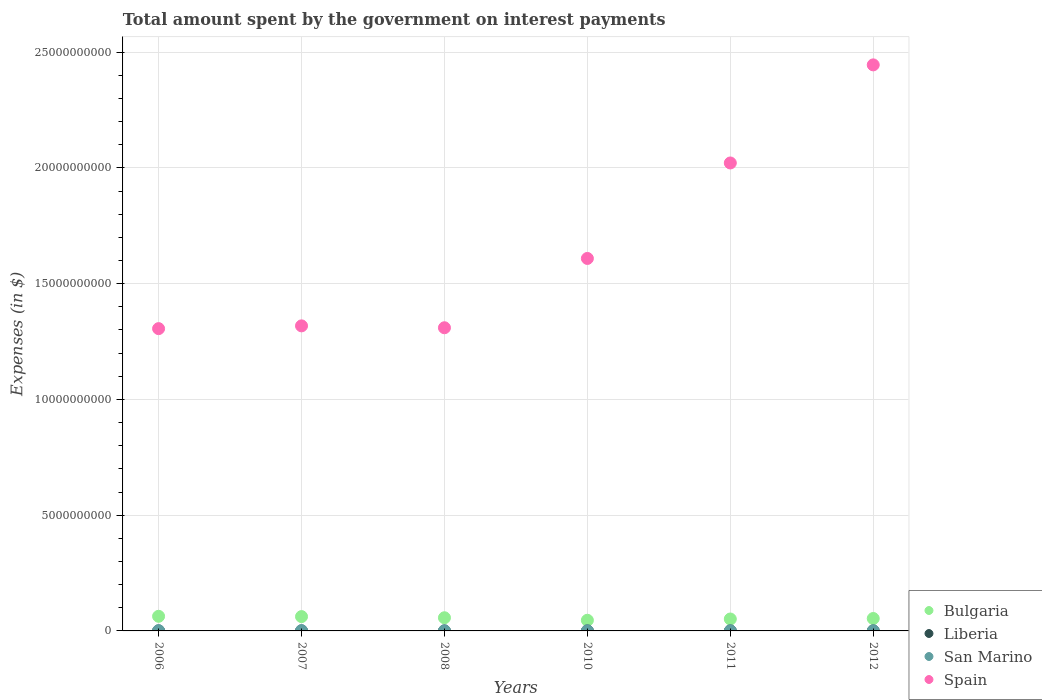What is the amount spent on interest payments by the government in San Marino in 2006?
Ensure brevity in your answer.  1.10e+07. Across all years, what is the maximum amount spent on interest payments by the government in San Marino?
Your answer should be compact. 1.27e+07. Across all years, what is the minimum amount spent on interest payments by the government in Bulgaria?
Provide a short and direct response. 4.60e+08. In which year was the amount spent on interest payments by the government in San Marino minimum?
Your answer should be compact. 2010. What is the total amount spent on interest payments by the government in Bulgaria in the graph?
Offer a very short reply. 3.33e+09. What is the difference between the amount spent on interest payments by the government in San Marino in 2010 and that in 2011?
Offer a terse response. -2.39e+05. What is the difference between the amount spent on interest payments by the government in Bulgaria in 2006 and the amount spent on interest payments by the government in Spain in 2010?
Ensure brevity in your answer.  -1.55e+1. What is the average amount spent on interest payments by the government in Bulgaria per year?
Give a very brief answer. 5.55e+08. In the year 2006, what is the difference between the amount spent on interest payments by the government in Liberia and amount spent on interest payments by the government in Spain?
Provide a succinct answer. -1.31e+1. In how many years, is the amount spent on interest payments by the government in San Marino greater than 8000000000 $?
Provide a short and direct response. 0. What is the ratio of the amount spent on interest payments by the government in Liberia in 2010 to that in 2011?
Offer a very short reply. 0.77. Is the difference between the amount spent on interest payments by the government in Liberia in 2006 and 2012 greater than the difference between the amount spent on interest payments by the government in Spain in 2006 and 2012?
Give a very brief answer. Yes. What is the difference between the highest and the second highest amount spent on interest payments by the government in Spain?
Make the answer very short. 4.24e+09. What is the difference between the highest and the lowest amount spent on interest payments by the government in Spain?
Ensure brevity in your answer.  1.14e+1. Is the sum of the amount spent on interest payments by the government in Bulgaria in 2008 and 2011 greater than the maximum amount spent on interest payments by the government in Spain across all years?
Your response must be concise. No. Is it the case that in every year, the sum of the amount spent on interest payments by the government in Liberia and amount spent on interest payments by the government in San Marino  is greater than the sum of amount spent on interest payments by the government in Spain and amount spent on interest payments by the government in Bulgaria?
Make the answer very short. No. Is it the case that in every year, the sum of the amount spent on interest payments by the government in San Marino and amount spent on interest payments by the government in Spain  is greater than the amount spent on interest payments by the government in Bulgaria?
Give a very brief answer. Yes. Does the amount spent on interest payments by the government in Bulgaria monotonically increase over the years?
Offer a terse response. No. Is the amount spent on interest payments by the government in San Marino strictly greater than the amount spent on interest payments by the government in Spain over the years?
Your answer should be very brief. No. Is the amount spent on interest payments by the government in San Marino strictly less than the amount spent on interest payments by the government in Liberia over the years?
Offer a very short reply. No. How many years are there in the graph?
Ensure brevity in your answer.  6. What is the difference between two consecutive major ticks on the Y-axis?
Give a very brief answer. 5.00e+09. How many legend labels are there?
Your answer should be very brief. 4. How are the legend labels stacked?
Offer a terse response. Vertical. What is the title of the graph?
Provide a succinct answer. Total amount spent by the government on interest payments. What is the label or title of the Y-axis?
Offer a terse response. Expenses (in $). What is the Expenses (in $) in Bulgaria in 2006?
Offer a very short reply. 6.32e+08. What is the Expenses (in $) in Liberia in 2006?
Provide a succinct answer. 2.07e+04. What is the Expenses (in $) in San Marino in 2006?
Give a very brief answer. 1.10e+07. What is the Expenses (in $) of Spain in 2006?
Keep it short and to the point. 1.31e+1. What is the Expenses (in $) in Bulgaria in 2007?
Your answer should be compact. 6.19e+08. What is the Expenses (in $) in Liberia in 2007?
Make the answer very short. 2.20e+04. What is the Expenses (in $) in San Marino in 2007?
Your answer should be compact. 1.27e+07. What is the Expenses (in $) in Spain in 2007?
Your answer should be compact. 1.32e+1. What is the Expenses (in $) of Bulgaria in 2008?
Give a very brief answer. 5.69e+08. What is the Expenses (in $) in Liberia in 2008?
Offer a very short reply. 7.01e+04. What is the Expenses (in $) of San Marino in 2008?
Your answer should be compact. 5.97e+06. What is the Expenses (in $) in Spain in 2008?
Give a very brief answer. 1.31e+1. What is the Expenses (in $) in Bulgaria in 2010?
Make the answer very short. 4.60e+08. What is the Expenses (in $) of Liberia in 2010?
Make the answer very short. 1.88e+05. What is the Expenses (in $) of San Marino in 2010?
Your answer should be very brief. 4.65e+06. What is the Expenses (in $) in Spain in 2010?
Your answer should be very brief. 1.61e+1. What is the Expenses (in $) in Bulgaria in 2011?
Provide a succinct answer. 5.15e+08. What is the Expenses (in $) of Liberia in 2011?
Keep it short and to the point. 2.44e+05. What is the Expenses (in $) of San Marino in 2011?
Your response must be concise. 4.89e+06. What is the Expenses (in $) in Spain in 2011?
Keep it short and to the point. 2.02e+1. What is the Expenses (in $) of Bulgaria in 2012?
Keep it short and to the point. 5.36e+08. What is the Expenses (in $) of Liberia in 2012?
Your answer should be compact. 4.63e+04. What is the Expenses (in $) of San Marino in 2012?
Offer a terse response. 5.06e+06. What is the Expenses (in $) in Spain in 2012?
Provide a succinct answer. 2.44e+1. Across all years, what is the maximum Expenses (in $) of Bulgaria?
Your answer should be very brief. 6.32e+08. Across all years, what is the maximum Expenses (in $) in Liberia?
Provide a short and direct response. 2.44e+05. Across all years, what is the maximum Expenses (in $) in San Marino?
Provide a succinct answer. 1.27e+07. Across all years, what is the maximum Expenses (in $) in Spain?
Your response must be concise. 2.44e+1. Across all years, what is the minimum Expenses (in $) in Bulgaria?
Provide a succinct answer. 4.60e+08. Across all years, what is the minimum Expenses (in $) in Liberia?
Offer a very short reply. 2.07e+04. Across all years, what is the minimum Expenses (in $) in San Marino?
Keep it short and to the point. 4.65e+06. Across all years, what is the minimum Expenses (in $) of Spain?
Your answer should be compact. 1.31e+1. What is the total Expenses (in $) in Bulgaria in the graph?
Provide a succinct answer. 3.33e+09. What is the total Expenses (in $) of Liberia in the graph?
Your response must be concise. 5.92e+05. What is the total Expenses (in $) of San Marino in the graph?
Your response must be concise. 4.43e+07. What is the total Expenses (in $) of Spain in the graph?
Keep it short and to the point. 1.00e+11. What is the difference between the Expenses (in $) in Bulgaria in 2006 and that in 2007?
Give a very brief answer. 1.30e+07. What is the difference between the Expenses (in $) in Liberia in 2006 and that in 2007?
Provide a succinct answer. -1373.52. What is the difference between the Expenses (in $) of San Marino in 2006 and that in 2007?
Keep it short and to the point. -1.77e+06. What is the difference between the Expenses (in $) in Spain in 2006 and that in 2007?
Provide a succinct answer. -1.20e+08. What is the difference between the Expenses (in $) in Bulgaria in 2006 and that in 2008?
Offer a very short reply. 6.30e+07. What is the difference between the Expenses (in $) in Liberia in 2006 and that in 2008?
Provide a succinct answer. -4.94e+04. What is the difference between the Expenses (in $) in San Marino in 2006 and that in 2008?
Ensure brevity in your answer.  5.00e+06. What is the difference between the Expenses (in $) in Spain in 2006 and that in 2008?
Offer a terse response. -3.80e+07. What is the difference between the Expenses (in $) of Bulgaria in 2006 and that in 2010?
Provide a short and direct response. 1.72e+08. What is the difference between the Expenses (in $) in Liberia in 2006 and that in 2010?
Your response must be concise. -1.68e+05. What is the difference between the Expenses (in $) in San Marino in 2006 and that in 2010?
Provide a short and direct response. 6.32e+06. What is the difference between the Expenses (in $) in Spain in 2006 and that in 2010?
Ensure brevity in your answer.  -3.03e+09. What is the difference between the Expenses (in $) in Bulgaria in 2006 and that in 2011?
Your answer should be very brief. 1.17e+08. What is the difference between the Expenses (in $) of Liberia in 2006 and that in 2011?
Your answer should be very brief. -2.24e+05. What is the difference between the Expenses (in $) of San Marino in 2006 and that in 2011?
Your answer should be very brief. 6.08e+06. What is the difference between the Expenses (in $) of Spain in 2006 and that in 2011?
Offer a very short reply. -7.16e+09. What is the difference between the Expenses (in $) of Bulgaria in 2006 and that in 2012?
Give a very brief answer. 9.56e+07. What is the difference between the Expenses (in $) in Liberia in 2006 and that in 2012?
Make the answer very short. -2.57e+04. What is the difference between the Expenses (in $) of San Marino in 2006 and that in 2012?
Provide a short and direct response. 5.90e+06. What is the difference between the Expenses (in $) in Spain in 2006 and that in 2012?
Your answer should be very brief. -1.14e+1. What is the difference between the Expenses (in $) in Bulgaria in 2007 and that in 2008?
Your answer should be compact. 5.00e+07. What is the difference between the Expenses (in $) of Liberia in 2007 and that in 2008?
Your answer should be compact. -4.80e+04. What is the difference between the Expenses (in $) of San Marino in 2007 and that in 2008?
Your response must be concise. 6.77e+06. What is the difference between the Expenses (in $) of Spain in 2007 and that in 2008?
Your response must be concise. 8.20e+07. What is the difference between the Expenses (in $) in Bulgaria in 2007 and that in 2010?
Provide a succinct answer. 1.59e+08. What is the difference between the Expenses (in $) in Liberia in 2007 and that in 2010?
Provide a succinct answer. -1.66e+05. What is the difference between the Expenses (in $) of San Marino in 2007 and that in 2010?
Your response must be concise. 8.09e+06. What is the difference between the Expenses (in $) of Spain in 2007 and that in 2010?
Provide a short and direct response. -2.91e+09. What is the difference between the Expenses (in $) of Bulgaria in 2007 and that in 2011?
Keep it short and to the point. 1.04e+08. What is the difference between the Expenses (in $) in Liberia in 2007 and that in 2011?
Your answer should be very brief. -2.22e+05. What is the difference between the Expenses (in $) of San Marino in 2007 and that in 2011?
Give a very brief answer. 7.85e+06. What is the difference between the Expenses (in $) of Spain in 2007 and that in 2011?
Ensure brevity in your answer.  -7.04e+09. What is the difference between the Expenses (in $) in Bulgaria in 2007 and that in 2012?
Offer a very short reply. 8.26e+07. What is the difference between the Expenses (in $) in Liberia in 2007 and that in 2012?
Your response must be concise. -2.43e+04. What is the difference between the Expenses (in $) of San Marino in 2007 and that in 2012?
Offer a terse response. 7.67e+06. What is the difference between the Expenses (in $) in Spain in 2007 and that in 2012?
Ensure brevity in your answer.  -1.13e+1. What is the difference between the Expenses (in $) of Bulgaria in 2008 and that in 2010?
Offer a very short reply. 1.09e+08. What is the difference between the Expenses (in $) of Liberia in 2008 and that in 2010?
Keep it short and to the point. -1.18e+05. What is the difference between the Expenses (in $) in San Marino in 2008 and that in 2010?
Ensure brevity in your answer.  1.32e+06. What is the difference between the Expenses (in $) of Spain in 2008 and that in 2010?
Offer a terse response. -2.99e+09. What is the difference between the Expenses (in $) of Bulgaria in 2008 and that in 2011?
Make the answer very short. 5.42e+07. What is the difference between the Expenses (in $) of Liberia in 2008 and that in 2011?
Keep it short and to the point. -1.74e+05. What is the difference between the Expenses (in $) of San Marino in 2008 and that in 2011?
Ensure brevity in your answer.  1.08e+06. What is the difference between the Expenses (in $) of Spain in 2008 and that in 2011?
Provide a succinct answer. -7.12e+09. What is the difference between the Expenses (in $) of Bulgaria in 2008 and that in 2012?
Keep it short and to the point. 3.26e+07. What is the difference between the Expenses (in $) of Liberia in 2008 and that in 2012?
Your answer should be very brief. 2.38e+04. What is the difference between the Expenses (in $) in San Marino in 2008 and that in 2012?
Offer a very short reply. 9.05e+05. What is the difference between the Expenses (in $) in Spain in 2008 and that in 2012?
Offer a terse response. -1.14e+1. What is the difference between the Expenses (in $) in Bulgaria in 2010 and that in 2011?
Ensure brevity in your answer.  -5.47e+07. What is the difference between the Expenses (in $) of Liberia in 2010 and that in 2011?
Your response must be concise. -5.61e+04. What is the difference between the Expenses (in $) of San Marino in 2010 and that in 2011?
Your answer should be compact. -2.39e+05. What is the difference between the Expenses (in $) of Spain in 2010 and that in 2011?
Provide a short and direct response. -4.12e+09. What is the difference between the Expenses (in $) of Bulgaria in 2010 and that in 2012?
Ensure brevity in your answer.  -7.62e+07. What is the difference between the Expenses (in $) of Liberia in 2010 and that in 2012?
Keep it short and to the point. 1.42e+05. What is the difference between the Expenses (in $) of San Marino in 2010 and that in 2012?
Your response must be concise. -4.13e+05. What is the difference between the Expenses (in $) in Spain in 2010 and that in 2012?
Keep it short and to the point. -8.36e+09. What is the difference between the Expenses (in $) of Bulgaria in 2011 and that in 2012?
Offer a terse response. -2.16e+07. What is the difference between the Expenses (in $) in Liberia in 2011 and that in 2012?
Your answer should be compact. 1.98e+05. What is the difference between the Expenses (in $) of San Marino in 2011 and that in 2012?
Your answer should be compact. -1.75e+05. What is the difference between the Expenses (in $) of Spain in 2011 and that in 2012?
Keep it short and to the point. -4.24e+09. What is the difference between the Expenses (in $) in Bulgaria in 2006 and the Expenses (in $) in Liberia in 2007?
Provide a succinct answer. 6.32e+08. What is the difference between the Expenses (in $) of Bulgaria in 2006 and the Expenses (in $) of San Marino in 2007?
Make the answer very short. 6.19e+08. What is the difference between the Expenses (in $) of Bulgaria in 2006 and the Expenses (in $) of Spain in 2007?
Your response must be concise. -1.25e+1. What is the difference between the Expenses (in $) in Liberia in 2006 and the Expenses (in $) in San Marino in 2007?
Provide a succinct answer. -1.27e+07. What is the difference between the Expenses (in $) in Liberia in 2006 and the Expenses (in $) in Spain in 2007?
Offer a terse response. -1.32e+1. What is the difference between the Expenses (in $) of San Marino in 2006 and the Expenses (in $) of Spain in 2007?
Make the answer very short. -1.32e+1. What is the difference between the Expenses (in $) in Bulgaria in 2006 and the Expenses (in $) in Liberia in 2008?
Ensure brevity in your answer.  6.32e+08. What is the difference between the Expenses (in $) in Bulgaria in 2006 and the Expenses (in $) in San Marino in 2008?
Make the answer very short. 6.26e+08. What is the difference between the Expenses (in $) in Bulgaria in 2006 and the Expenses (in $) in Spain in 2008?
Keep it short and to the point. -1.25e+1. What is the difference between the Expenses (in $) in Liberia in 2006 and the Expenses (in $) in San Marino in 2008?
Provide a short and direct response. -5.95e+06. What is the difference between the Expenses (in $) of Liberia in 2006 and the Expenses (in $) of Spain in 2008?
Give a very brief answer. -1.31e+1. What is the difference between the Expenses (in $) of San Marino in 2006 and the Expenses (in $) of Spain in 2008?
Your response must be concise. -1.31e+1. What is the difference between the Expenses (in $) of Bulgaria in 2006 and the Expenses (in $) of Liberia in 2010?
Give a very brief answer. 6.32e+08. What is the difference between the Expenses (in $) of Bulgaria in 2006 and the Expenses (in $) of San Marino in 2010?
Provide a succinct answer. 6.27e+08. What is the difference between the Expenses (in $) in Bulgaria in 2006 and the Expenses (in $) in Spain in 2010?
Keep it short and to the point. -1.55e+1. What is the difference between the Expenses (in $) in Liberia in 2006 and the Expenses (in $) in San Marino in 2010?
Give a very brief answer. -4.63e+06. What is the difference between the Expenses (in $) in Liberia in 2006 and the Expenses (in $) in Spain in 2010?
Your answer should be very brief. -1.61e+1. What is the difference between the Expenses (in $) of San Marino in 2006 and the Expenses (in $) of Spain in 2010?
Your answer should be compact. -1.61e+1. What is the difference between the Expenses (in $) of Bulgaria in 2006 and the Expenses (in $) of Liberia in 2011?
Keep it short and to the point. 6.31e+08. What is the difference between the Expenses (in $) in Bulgaria in 2006 and the Expenses (in $) in San Marino in 2011?
Provide a short and direct response. 6.27e+08. What is the difference between the Expenses (in $) of Bulgaria in 2006 and the Expenses (in $) of Spain in 2011?
Provide a succinct answer. -1.96e+1. What is the difference between the Expenses (in $) in Liberia in 2006 and the Expenses (in $) in San Marino in 2011?
Ensure brevity in your answer.  -4.87e+06. What is the difference between the Expenses (in $) of Liberia in 2006 and the Expenses (in $) of Spain in 2011?
Offer a terse response. -2.02e+1. What is the difference between the Expenses (in $) in San Marino in 2006 and the Expenses (in $) in Spain in 2011?
Your response must be concise. -2.02e+1. What is the difference between the Expenses (in $) of Bulgaria in 2006 and the Expenses (in $) of Liberia in 2012?
Your answer should be compact. 6.32e+08. What is the difference between the Expenses (in $) of Bulgaria in 2006 and the Expenses (in $) of San Marino in 2012?
Ensure brevity in your answer.  6.27e+08. What is the difference between the Expenses (in $) in Bulgaria in 2006 and the Expenses (in $) in Spain in 2012?
Make the answer very short. -2.38e+1. What is the difference between the Expenses (in $) of Liberia in 2006 and the Expenses (in $) of San Marino in 2012?
Your answer should be compact. -5.04e+06. What is the difference between the Expenses (in $) of Liberia in 2006 and the Expenses (in $) of Spain in 2012?
Provide a succinct answer. -2.44e+1. What is the difference between the Expenses (in $) in San Marino in 2006 and the Expenses (in $) in Spain in 2012?
Provide a succinct answer. -2.44e+1. What is the difference between the Expenses (in $) in Bulgaria in 2007 and the Expenses (in $) in Liberia in 2008?
Keep it short and to the point. 6.19e+08. What is the difference between the Expenses (in $) of Bulgaria in 2007 and the Expenses (in $) of San Marino in 2008?
Your response must be concise. 6.13e+08. What is the difference between the Expenses (in $) of Bulgaria in 2007 and the Expenses (in $) of Spain in 2008?
Provide a succinct answer. -1.25e+1. What is the difference between the Expenses (in $) of Liberia in 2007 and the Expenses (in $) of San Marino in 2008?
Provide a succinct answer. -5.95e+06. What is the difference between the Expenses (in $) of Liberia in 2007 and the Expenses (in $) of Spain in 2008?
Offer a very short reply. -1.31e+1. What is the difference between the Expenses (in $) of San Marino in 2007 and the Expenses (in $) of Spain in 2008?
Your response must be concise. -1.31e+1. What is the difference between the Expenses (in $) in Bulgaria in 2007 and the Expenses (in $) in Liberia in 2010?
Ensure brevity in your answer.  6.19e+08. What is the difference between the Expenses (in $) of Bulgaria in 2007 and the Expenses (in $) of San Marino in 2010?
Your answer should be compact. 6.14e+08. What is the difference between the Expenses (in $) of Bulgaria in 2007 and the Expenses (in $) of Spain in 2010?
Keep it short and to the point. -1.55e+1. What is the difference between the Expenses (in $) in Liberia in 2007 and the Expenses (in $) in San Marino in 2010?
Keep it short and to the point. -4.63e+06. What is the difference between the Expenses (in $) in Liberia in 2007 and the Expenses (in $) in Spain in 2010?
Give a very brief answer. -1.61e+1. What is the difference between the Expenses (in $) in San Marino in 2007 and the Expenses (in $) in Spain in 2010?
Ensure brevity in your answer.  -1.61e+1. What is the difference between the Expenses (in $) of Bulgaria in 2007 and the Expenses (in $) of Liberia in 2011?
Offer a terse response. 6.18e+08. What is the difference between the Expenses (in $) of Bulgaria in 2007 and the Expenses (in $) of San Marino in 2011?
Ensure brevity in your answer.  6.14e+08. What is the difference between the Expenses (in $) in Bulgaria in 2007 and the Expenses (in $) in Spain in 2011?
Give a very brief answer. -1.96e+1. What is the difference between the Expenses (in $) in Liberia in 2007 and the Expenses (in $) in San Marino in 2011?
Give a very brief answer. -4.87e+06. What is the difference between the Expenses (in $) in Liberia in 2007 and the Expenses (in $) in Spain in 2011?
Give a very brief answer. -2.02e+1. What is the difference between the Expenses (in $) in San Marino in 2007 and the Expenses (in $) in Spain in 2011?
Provide a succinct answer. -2.02e+1. What is the difference between the Expenses (in $) of Bulgaria in 2007 and the Expenses (in $) of Liberia in 2012?
Offer a terse response. 6.19e+08. What is the difference between the Expenses (in $) in Bulgaria in 2007 and the Expenses (in $) in San Marino in 2012?
Offer a very short reply. 6.14e+08. What is the difference between the Expenses (in $) of Bulgaria in 2007 and the Expenses (in $) of Spain in 2012?
Give a very brief answer. -2.38e+1. What is the difference between the Expenses (in $) in Liberia in 2007 and the Expenses (in $) in San Marino in 2012?
Make the answer very short. -5.04e+06. What is the difference between the Expenses (in $) in Liberia in 2007 and the Expenses (in $) in Spain in 2012?
Give a very brief answer. -2.44e+1. What is the difference between the Expenses (in $) in San Marino in 2007 and the Expenses (in $) in Spain in 2012?
Your answer should be very brief. -2.44e+1. What is the difference between the Expenses (in $) in Bulgaria in 2008 and the Expenses (in $) in Liberia in 2010?
Provide a short and direct response. 5.69e+08. What is the difference between the Expenses (in $) of Bulgaria in 2008 and the Expenses (in $) of San Marino in 2010?
Offer a terse response. 5.64e+08. What is the difference between the Expenses (in $) in Bulgaria in 2008 and the Expenses (in $) in Spain in 2010?
Offer a very short reply. -1.55e+1. What is the difference between the Expenses (in $) of Liberia in 2008 and the Expenses (in $) of San Marino in 2010?
Keep it short and to the point. -4.58e+06. What is the difference between the Expenses (in $) of Liberia in 2008 and the Expenses (in $) of Spain in 2010?
Make the answer very short. -1.61e+1. What is the difference between the Expenses (in $) in San Marino in 2008 and the Expenses (in $) in Spain in 2010?
Your answer should be very brief. -1.61e+1. What is the difference between the Expenses (in $) in Bulgaria in 2008 and the Expenses (in $) in Liberia in 2011?
Make the answer very short. 5.69e+08. What is the difference between the Expenses (in $) in Bulgaria in 2008 and the Expenses (in $) in San Marino in 2011?
Offer a terse response. 5.64e+08. What is the difference between the Expenses (in $) of Bulgaria in 2008 and the Expenses (in $) of Spain in 2011?
Make the answer very short. -1.96e+1. What is the difference between the Expenses (in $) of Liberia in 2008 and the Expenses (in $) of San Marino in 2011?
Make the answer very short. -4.82e+06. What is the difference between the Expenses (in $) of Liberia in 2008 and the Expenses (in $) of Spain in 2011?
Make the answer very short. -2.02e+1. What is the difference between the Expenses (in $) of San Marino in 2008 and the Expenses (in $) of Spain in 2011?
Give a very brief answer. -2.02e+1. What is the difference between the Expenses (in $) in Bulgaria in 2008 and the Expenses (in $) in Liberia in 2012?
Give a very brief answer. 5.69e+08. What is the difference between the Expenses (in $) in Bulgaria in 2008 and the Expenses (in $) in San Marino in 2012?
Offer a very short reply. 5.64e+08. What is the difference between the Expenses (in $) of Bulgaria in 2008 and the Expenses (in $) of Spain in 2012?
Ensure brevity in your answer.  -2.39e+1. What is the difference between the Expenses (in $) of Liberia in 2008 and the Expenses (in $) of San Marino in 2012?
Your answer should be very brief. -4.99e+06. What is the difference between the Expenses (in $) in Liberia in 2008 and the Expenses (in $) in Spain in 2012?
Ensure brevity in your answer.  -2.44e+1. What is the difference between the Expenses (in $) in San Marino in 2008 and the Expenses (in $) in Spain in 2012?
Provide a succinct answer. -2.44e+1. What is the difference between the Expenses (in $) in Bulgaria in 2010 and the Expenses (in $) in Liberia in 2011?
Your answer should be very brief. 4.60e+08. What is the difference between the Expenses (in $) in Bulgaria in 2010 and the Expenses (in $) in San Marino in 2011?
Provide a succinct answer. 4.55e+08. What is the difference between the Expenses (in $) of Bulgaria in 2010 and the Expenses (in $) of Spain in 2011?
Provide a short and direct response. -1.98e+1. What is the difference between the Expenses (in $) of Liberia in 2010 and the Expenses (in $) of San Marino in 2011?
Make the answer very short. -4.70e+06. What is the difference between the Expenses (in $) of Liberia in 2010 and the Expenses (in $) of Spain in 2011?
Offer a terse response. -2.02e+1. What is the difference between the Expenses (in $) in San Marino in 2010 and the Expenses (in $) in Spain in 2011?
Ensure brevity in your answer.  -2.02e+1. What is the difference between the Expenses (in $) in Bulgaria in 2010 and the Expenses (in $) in Liberia in 2012?
Your response must be concise. 4.60e+08. What is the difference between the Expenses (in $) of Bulgaria in 2010 and the Expenses (in $) of San Marino in 2012?
Make the answer very short. 4.55e+08. What is the difference between the Expenses (in $) in Bulgaria in 2010 and the Expenses (in $) in Spain in 2012?
Your answer should be very brief. -2.40e+1. What is the difference between the Expenses (in $) in Liberia in 2010 and the Expenses (in $) in San Marino in 2012?
Offer a very short reply. -4.88e+06. What is the difference between the Expenses (in $) in Liberia in 2010 and the Expenses (in $) in Spain in 2012?
Give a very brief answer. -2.44e+1. What is the difference between the Expenses (in $) in San Marino in 2010 and the Expenses (in $) in Spain in 2012?
Keep it short and to the point. -2.44e+1. What is the difference between the Expenses (in $) in Bulgaria in 2011 and the Expenses (in $) in Liberia in 2012?
Offer a terse response. 5.15e+08. What is the difference between the Expenses (in $) in Bulgaria in 2011 and the Expenses (in $) in San Marino in 2012?
Offer a terse response. 5.10e+08. What is the difference between the Expenses (in $) of Bulgaria in 2011 and the Expenses (in $) of Spain in 2012?
Your answer should be compact. -2.39e+1. What is the difference between the Expenses (in $) of Liberia in 2011 and the Expenses (in $) of San Marino in 2012?
Offer a terse response. -4.82e+06. What is the difference between the Expenses (in $) of Liberia in 2011 and the Expenses (in $) of Spain in 2012?
Keep it short and to the point. -2.44e+1. What is the difference between the Expenses (in $) of San Marino in 2011 and the Expenses (in $) of Spain in 2012?
Offer a very short reply. -2.44e+1. What is the average Expenses (in $) in Bulgaria per year?
Keep it short and to the point. 5.55e+08. What is the average Expenses (in $) in Liberia per year?
Your answer should be compact. 9.86e+04. What is the average Expenses (in $) of San Marino per year?
Your answer should be very brief. 7.38e+06. What is the average Expenses (in $) of Spain per year?
Ensure brevity in your answer.  1.67e+1. In the year 2006, what is the difference between the Expenses (in $) of Bulgaria and Expenses (in $) of Liberia?
Your answer should be compact. 6.32e+08. In the year 2006, what is the difference between the Expenses (in $) of Bulgaria and Expenses (in $) of San Marino?
Provide a short and direct response. 6.21e+08. In the year 2006, what is the difference between the Expenses (in $) of Bulgaria and Expenses (in $) of Spain?
Provide a short and direct response. -1.24e+1. In the year 2006, what is the difference between the Expenses (in $) of Liberia and Expenses (in $) of San Marino?
Your answer should be compact. -1.09e+07. In the year 2006, what is the difference between the Expenses (in $) of Liberia and Expenses (in $) of Spain?
Your response must be concise. -1.31e+1. In the year 2006, what is the difference between the Expenses (in $) in San Marino and Expenses (in $) in Spain?
Provide a short and direct response. -1.30e+1. In the year 2007, what is the difference between the Expenses (in $) in Bulgaria and Expenses (in $) in Liberia?
Offer a terse response. 6.19e+08. In the year 2007, what is the difference between the Expenses (in $) of Bulgaria and Expenses (in $) of San Marino?
Ensure brevity in your answer.  6.06e+08. In the year 2007, what is the difference between the Expenses (in $) in Bulgaria and Expenses (in $) in Spain?
Keep it short and to the point. -1.26e+1. In the year 2007, what is the difference between the Expenses (in $) in Liberia and Expenses (in $) in San Marino?
Give a very brief answer. -1.27e+07. In the year 2007, what is the difference between the Expenses (in $) in Liberia and Expenses (in $) in Spain?
Ensure brevity in your answer.  -1.32e+1. In the year 2007, what is the difference between the Expenses (in $) in San Marino and Expenses (in $) in Spain?
Provide a succinct answer. -1.32e+1. In the year 2008, what is the difference between the Expenses (in $) in Bulgaria and Expenses (in $) in Liberia?
Make the answer very short. 5.69e+08. In the year 2008, what is the difference between the Expenses (in $) of Bulgaria and Expenses (in $) of San Marino?
Provide a short and direct response. 5.63e+08. In the year 2008, what is the difference between the Expenses (in $) of Bulgaria and Expenses (in $) of Spain?
Make the answer very short. -1.25e+1. In the year 2008, what is the difference between the Expenses (in $) in Liberia and Expenses (in $) in San Marino?
Make the answer very short. -5.90e+06. In the year 2008, what is the difference between the Expenses (in $) of Liberia and Expenses (in $) of Spain?
Your answer should be compact. -1.31e+1. In the year 2008, what is the difference between the Expenses (in $) of San Marino and Expenses (in $) of Spain?
Provide a succinct answer. -1.31e+1. In the year 2010, what is the difference between the Expenses (in $) in Bulgaria and Expenses (in $) in Liberia?
Make the answer very short. 4.60e+08. In the year 2010, what is the difference between the Expenses (in $) of Bulgaria and Expenses (in $) of San Marino?
Offer a very short reply. 4.55e+08. In the year 2010, what is the difference between the Expenses (in $) of Bulgaria and Expenses (in $) of Spain?
Your response must be concise. -1.56e+1. In the year 2010, what is the difference between the Expenses (in $) in Liberia and Expenses (in $) in San Marino?
Your answer should be very brief. -4.46e+06. In the year 2010, what is the difference between the Expenses (in $) in Liberia and Expenses (in $) in Spain?
Make the answer very short. -1.61e+1. In the year 2010, what is the difference between the Expenses (in $) in San Marino and Expenses (in $) in Spain?
Your response must be concise. -1.61e+1. In the year 2011, what is the difference between the Expenses (in $) in Bulgaria and Expenses (in $) in Liberia?
Your response must be concise. 5.14e+08. In the year 2011, what is the difference between the Expenses (in $) of Bulgaria and Expenses (in $) of San Marino?
Your answer should be very brief. 5.10e+08. In the year 2011, what is the difference between the Expenses (in $) in Bulgaria and Expenses (in $) in Spain?
Offer a very short reply. -1.97e+1. In the year 2011, what is the difference between the Expenses (in $) in Liberia and Expenses (in $) in San Marino?
Give a very brief answer. -4.65e+06. In the year 2011, what is the difference between the Expenses (in $) of Liberia and Expenses (in $) of Spain?
Provide a short and direct response. -2.02e+1. In the year 2011, what is the difference between the Expenses (in $) of San Marino and Expenses (in $) of Spain?
Keep it short and to the point. -2.02e+1. In the year 2012, what is the difference between the Expenses (in $) in Bulgaria and Expenses (in $) in Liberia?
Make the answer very short. 5.36e+08. In the year 2012, what is the difference between the Expenses (in $) in Bulgaria and Expenses (in $) in San Marino?
Your response must be concise. 5.31e+08. In the year 2012, what is the difference between the Expenses (in $) of Bulgaria and Expenses (in $) of Spain?
Your response must be concise. -2.39e+1. In the year 2012, what is the difference between the Expenses (in $) of Liberia and Expenses (in $) of San Marino?
Your answer should be very brief. -5.02e+06. In the year 2012, what is the difference between the Expenses (in $) of Liberia and Expenses (in $) of Spain?
Your response must be concise. -2.44e+1. In the year 2012, what is the difference between the Expenses (in $) in San Marino and Expenses (in $) in Spain?
Offer a terse response. -2.44e+1. What is the ratio of the Expenses (in $) of Bulgaria in 2006 to that in 2007?
Ensure brevity in your answer.  1.02. What is the ratio of the Expenses (in $) in Liberia in 2006 to that in 2007?
Ensure brevity in your answer.  0.94. What is the ratio of the Expenses (in $) in San Marino in 2006 to that in 2007?
Your answer should be very brief. 0.86. What is the ratio of the Expenses (in $) in Spain in 2006 to that in 2007?
Provide a succinct answer. 0.99. What is the ratio of the Expenses (in $) in Bulgaria in 2006 to that in 2008?
Provide a short and direct response. 1.11. What is the ratio of the Expenses (in $) in Liberia in 2006 to that in 2008?
Offer a very short reply. 0.29. What is the ratio of the Expenses (in $) of San Marino in 2006 to that in 2008?
Provide a short and direct response. 1.84. What is the ratio of the Expenses (in $) in Bulgaria in 2006 to that in 2010?
Offer a terse response. 1.37. What is the ratio of the Expenses (in $) of Liberia in 2006 to that in 2010?
Provide a short and direct response. 0.11. What is the ratio of the Expenses (in $) of San Marino in 2006 to that in 2010?
Provide a succinct answer. 2.36. What is the ratio of the Expenses (in $) in Spain in 2006 to that in 2010?
Provide a succinct answer. 0.81. What is the ratio of the Expenses (in $) of Bulgaria in 2006 to that in 2011?
Your answer should be very brief. 1.23. What is the ratio of the Expenses (in $) of Liberia in 2006 to that in 2011?
Provide a succinct answer. 0.08. What is the ratio of the Expenses (in $) in San Marino in 2006 to that in 2011?
Your answer should be very brief. 2.24. What is the ratio of the Expenses (in $) in Spain in 2006 to that in 2011?
Ensure brevity in your answer.  0.65. What is the ratio of the Expenses (in $) in Bulgaria in 2006 to that in 2012?
Provide a short and direct response. 1.18. What is the ratio of the Expenses (in $) in Liberia in 2006 to that in 2012?
Provide a succinct answer. 0.45. What is the ratio of the Expenses (in $) of San Marino in 2006 to that in 2012?
Your response must be concise. 2.17. What is the ratio of the Expenses (in $) of Spain in 2006 to that in 2012?
Your answer should be compact. 0.53. What is the ratio of the Expenses (in $) of Bulgaria in 2007 to that in 2008?
Make the answer very short. 1.09. What is the ratio of the Expenses (in $) in Liberia in 2007 to that in 2008?
Keep it short and to the point. 0.31. What is the ratio of the Expenses (in $) of San Marino in 2007 to that in 2008?
Provide a succinct answer. 2.13. What is the ratio of the Expenses (in $) of Spain in 2007 to that in 2008?
Your response must be concise. 1.01. What is the ratio of the Expenses (in $) of Bulgaria in 2007 to that in 2010?
Ensure brevity in your answer.  1.35. What is the ratio of the Expenses (in $) in Liberia in 2007 to that in 2010?
Offer a terse response. 0.12. What is the ratio of the Expenses (in $) of San Marino in 2007 to that in 2010?
Your answer should be very brief. 2.74. What is the ratio of the Expenses (in $) of Spain in 2007 to that in 2010?
Give a very brief answer. 0.82. What is the ratio of the Expenses (in $) of Bulgaria in 2007 to that in 2011?
Keep it short and to the point. 1.2. What is the ratio of the Expenses (in $) in Liberia in 2007 to that in 2011?
Your response must be concise. 0.09. What is the ratio of the Expenses (in $) of San Marino in 2007 to that in 2011?
Your answer should be very brief. 2.6. What is the ratio of the Expenses (in $) in Spain in 2007 to that in 2011?
Keep it short and to the point. 0.65. What is the ratio of the Expenses (in $) of Bulgaria in 2007 to that in 2012?
Give a very brief answer. 1.15. What is the ratio of the Expenses (in $) in Liberia in 2007 to that in 2012?
Your answer should be compact. 0.48. What is the ratio of the Expenses (in $) of San Marino in 2007 to that in 2012?
Your response must be concise. 2.52. What is the ratio of the Expenses (in $) of Spain in 2007 to that in 2012?
Provide a short and direct response. 0.54. What is the ratio of the Expenses (in $) in Bulgaria in 2008 to that in 2010?
Offer a terse response. 1.24. What is the ratio of the Expenses (in $) in Liberia in 2008 to that in 2010?
Your answer should be compact. 0.37. What is the ratio of the Expenses (in $) in San Marino in 2008 to that in 2010?
Ensure brevity in your answer.  1.28. What is the ratio of the Expenses (in $) of Spain in 2008 to that in 2010?
Make the answer very short. 0.81. What is the ratio of the Expenses (in $) in Bulgaria in 2008 to that in 2011?
Your answer should be compact. 1.11. What is the ratio of the Expenses (in $) in Liberia in 2008 to that in 2011?
Offer a terse response. 0.29. What is the ratio of the Expenses (in $) of San Marino in 2008 to that in 2011?
Give a very brief answer. 1.22. What is the ratio of the Expenses (in $) in Spain in 2008 to that in 2011?
Offer a very short reply. 0.65. What is the ratio of the Expenses (in $) in Bulgaria in 2008 to that in 2012?
Keep it short and to the point. 1.06. What is the ratio of the Expenses (in $) of Liberia in 2008 to that in 2012?
Make the answer very short. 1.51. What is the ratio of the Expenses (in $) in San Marino in 2008 to that in 2012?
Your answer should be compact. 1.18. What is the ratio of the Expenses (in $) of Spain in 2008 to that in 2012?
Ensure brevity in your answer.  0.54. What is the ratio of the Expenses (in $) in Bulgaria in 2010 to that in 2011?
Offer a very short reply. 0.89. What is the ratio of the Expenses (in $) of Liberia in 2010 to that in 2011?
Offer a very short reply. 0.77. What is the ratio of the Expenses (in $) in San Marino in 2010 to that in 2011?
Provide a succinct answer. 0.95. What is the ratio of the Expenses (in $) in Spain in 2010 to that in 2011?
Your answer should be very brief. 0.8. What is the ratio of the Expenses (in $) of Bulgaria in 2010 to that in 2012?
Offer a very short reply. 0.86. What is the ratio of the Expenses (in $) in Liberia in 2010 to that in 2012?
Make the answer very short. 4.06. What is the ratio of the Expenses (in $) of San Marino in 2010 to that in 2012?
Provide a succinct answer. 0.92. What is the ratio of the Expenses (in $) in Spain in 2010 to that in 2012?
Give a very brief answer. 0.66. What is the ratio of the Expenses (in $) in Bulgaria in 2011 to that in 2012?
Your answer should be compact. 0.96. What is the ratio of the Expenses (in $) in Liberia in 2011 to that in 2012?
Keep it short and to the point. 5.28. What is the ratio of the Expenses (in $) of San Marino in 2011 to that in 2012?
Provide a succinct answer. 0.97. What is the ratio of the Expenses (in $) of Spain in 2011 to that in 2012?
Your answer should be very brief. 0.83. What is the difference between the highest and the second highest Expenses (in $) in Bulgaria?
Offer a terse response. 1.30e+07. What is the difference between the highest and the second highest Expenses (in $) of Liberia?
Ensure brevity in your answer.  5.61e+04. What is the difference between the highest and the second highest Expenses (in $) of San Marino?
Make the answer very short. 1.77e+06. What is the difference between the highest and the second highest Expenses (in $) in Spain?
Provide a succinct answer. 4.24e+09. What is the difference between the highest and the lowest Expenses (in $) of Bulgaria?
Ensure brevity in your answer.  1.72e+08. What is the difference between the highest and the lowest Expenses (in $) in Liberia?
Ensure brevity in your answer.  2.24e+05. What is the difference between the highest and the lowest Expenses (in $) of San Marino?
Give a very brief answer. 8.09e+06. What is the difference between the highest and the lowest Expenses (in $) of Spain?
Make the answer very short. 1.14e+1. 